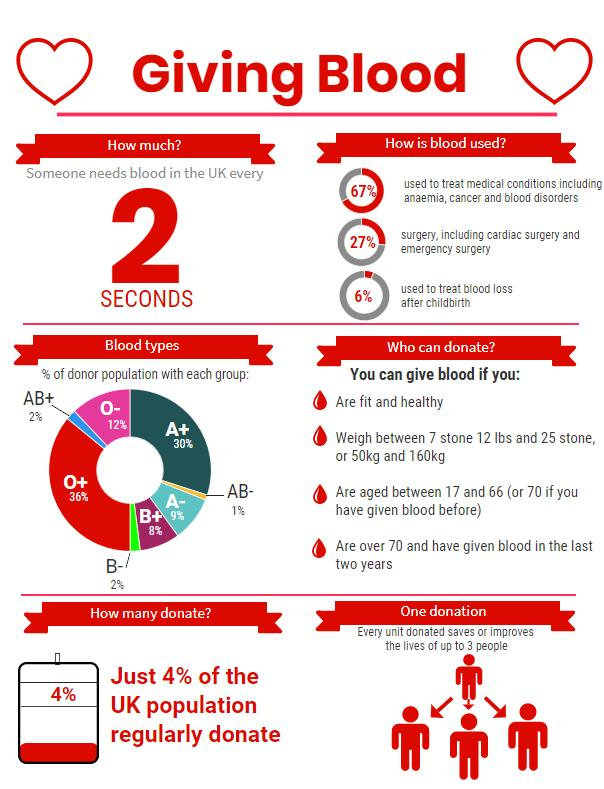Mention a couple of crucial points in this snapshot. The type of blood group with the least percentage of donor population in the UK is AB-. In the United Kingdom, it is estimated that 36% of the donor population has the O+ blood group. In the UK, approximately 30% of the donor population has the A+ blood group. According to data, a staggering 96% of the UK donor population do not donate blood regularly. In the United Kingdom, it is estimated that approximately 12% of the donor population has the O- blood group. 